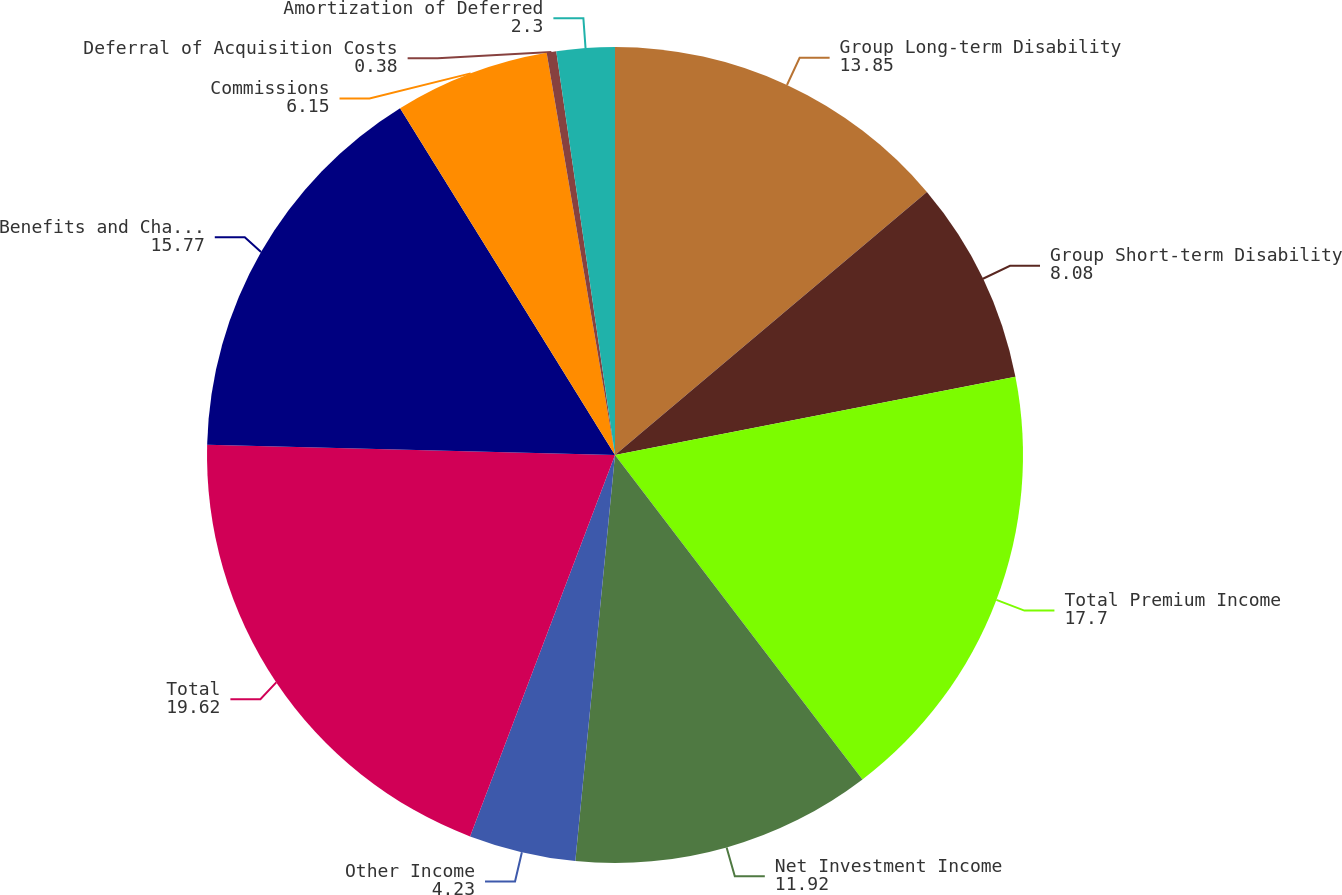Convert chart to OTSL. <chart><loc_0><loc_0><loc_500><loc_500><pie_chart><fcel>Group Long-term Disability<fcel>Group Short-term Disability<fcel>Total Premium Income<fcel>Net Investment Income<fcel>Other Income<fcel>Total<fcel>Benefits and Change in<fcel>Commissions<fcel>Deferral of Acquisition Costs<fcel>Amortization of Deferred<nl><fcel>13.85%<fcel>8.08%<fcel>17.7%<fcel>11.92%<fcel>4.23%<fcel>19.62%<fcel>15.77%<fcel>6.15%<fcel>0.38%<fcel>2.3%<nl></chart> 